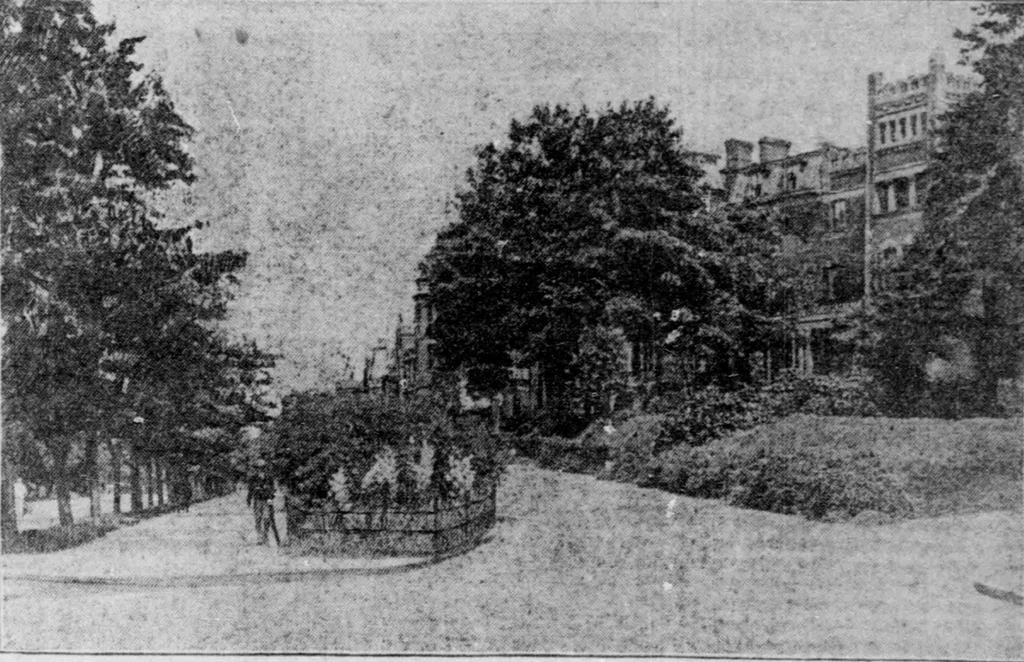What is the age of the image? The image is old. What type of natural environment is depicted in the image? There are many trees in the image. What type of structures can be seen behind the trees? There are buildings behind the trees in the image. What type of collar is visible on the trees in the image? There are no collars present on the trees in the image. What type of government is depicted in the image? The image does not depict any government or political entity. 